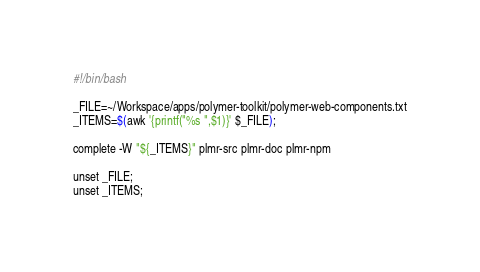<code> <loc_0><loc_0><loc_500><loc_500><_Bash_>#!/bin/bash

_FILE=~/Workspace/apps/polymer-toolkit/polymer-web-components.txt
_ITEMS=$(awk '{printf("%s ",$1)}' $_FILE);

complete -W "${_ITEMS}" plmr-src plmr-doc plmr-npm

unset _FILE;
unset _ITEMS;
</code> 